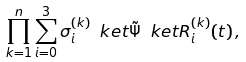<formula> <loc_0><loc_0><loc_500><loc_500>\prod _ { k = 1 } ^ { n } \sum _ { i = 0 } ^ { 3 } \sigma _ { i } ^ { ( k ) } \ k e t { \tilde { \Psi } } \ k e t { R _ { i } ^ { ( k ) } ( t ) } \, ,</formula> 